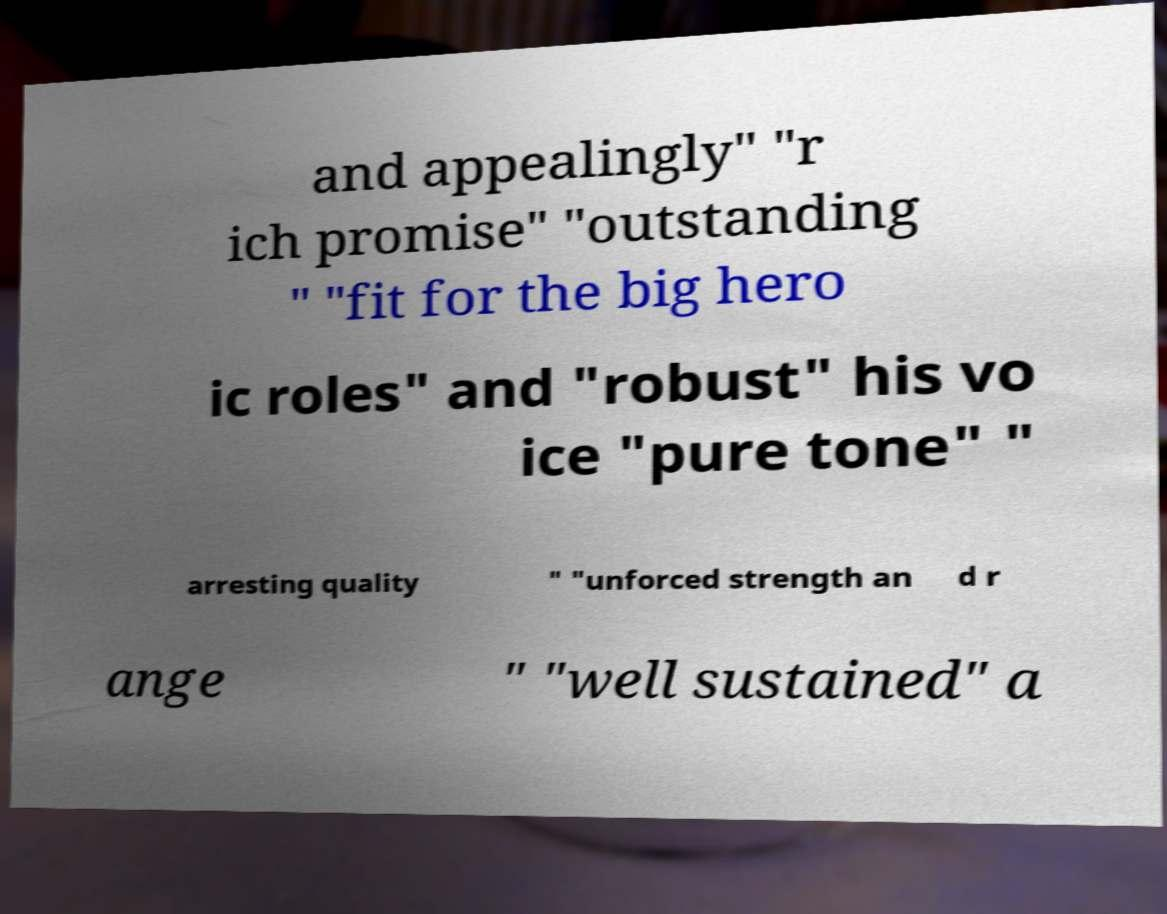What messages or text are displayed in this image? I need them in a readable, typed format. and appealingly" "r ich promise" "outstanding " "fit for the big hero ic roles" and "robust" his vo ice "pure tone" " arresting quality " "unforced strength an d r ange " "well sustained" a 